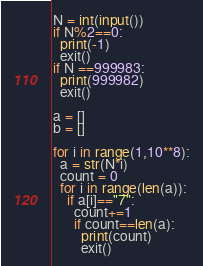<code> <loc_0><loc_0><loc_500><loc_500><_Python_>N = int(input())
if N%2==0:
  print(-1)
  exit()
if N ==999983:
  print(999982)
  exit()

a = []
b = []

for i in range(1,10**8):
  a = str(N*i)
  count = 0
  for i in range(len(a)):
    if a[i]=="7":
      count+=1
      if count==len(a):
        print(count)
        exit()</code> 